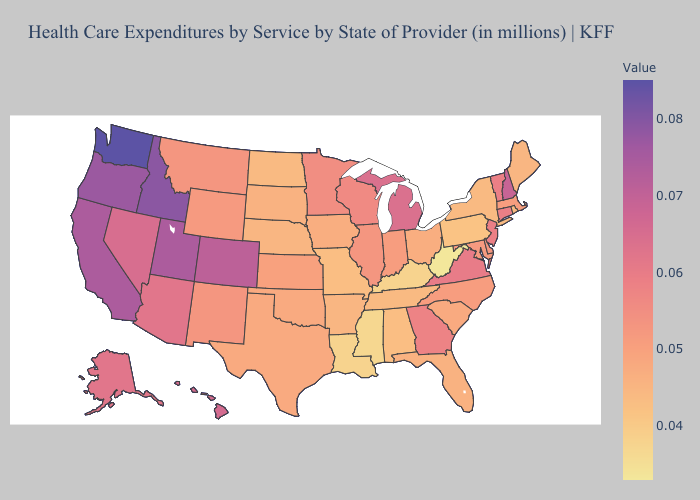Among the states that border Nevada , which have the lowest value?
Keep it brief. Arizona. Does West Virginia have the lowest value in the USA?
Answer briefly. Yes. Does Ohio have the highest value in the USA?
Quick response, please. No. Does Montana have a higher value than Maine?
Quick response, please. Yes. 